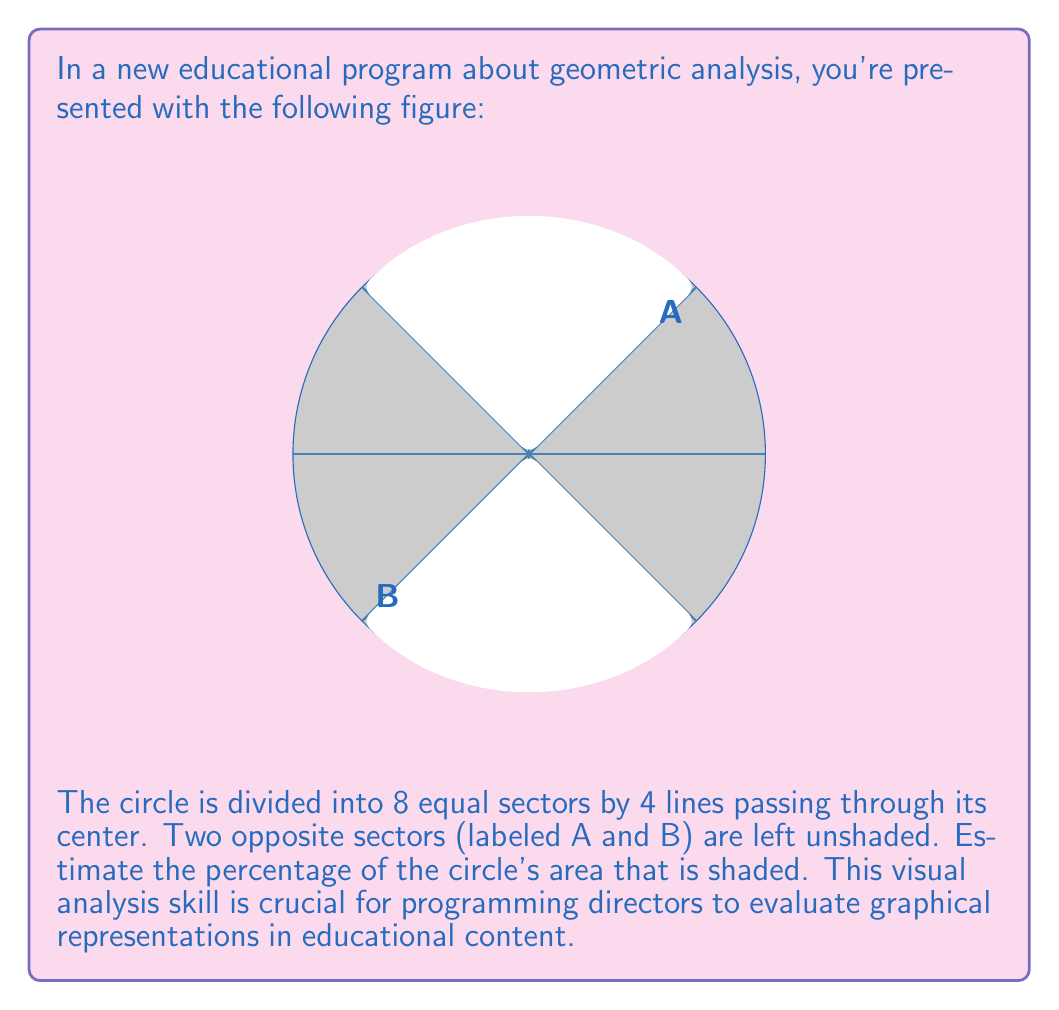Teach me how to tackle this problem. To solve this problem, let's break it down into steps:

1) First, we need to understand what fraction of the circle each sector represents:
   - The circle is divided into 8 equal sectors
   - Each sector represents $\frac{1}{8}$ of the total area

2) Now, let's count the number of shaded sectors:
   - There are 6 shaded sectors out of 8 total sectors

3) To calculate the fraction of the circle that is shaded:
   $$\text{Shaded fraction} = \frac{\text{Number of shaded sectors}}{\text{Total number of sectors}} = \frac{6}{8}$$

4) Simplify this fraction:
   $$\frac{6}{8} = \frac{3}{4} = 0.75$$

5) To convert to a percentage, multiply by 100:
   $$0.75 \times 100 = 75\%$$

Therefore, approximately 75% of the circle's area is shaded.

This type of visual estimation is valuable in programming and content creation, as it allows for quick assessment of graphical elements without the need for precise measurements.
Answer: 75% 